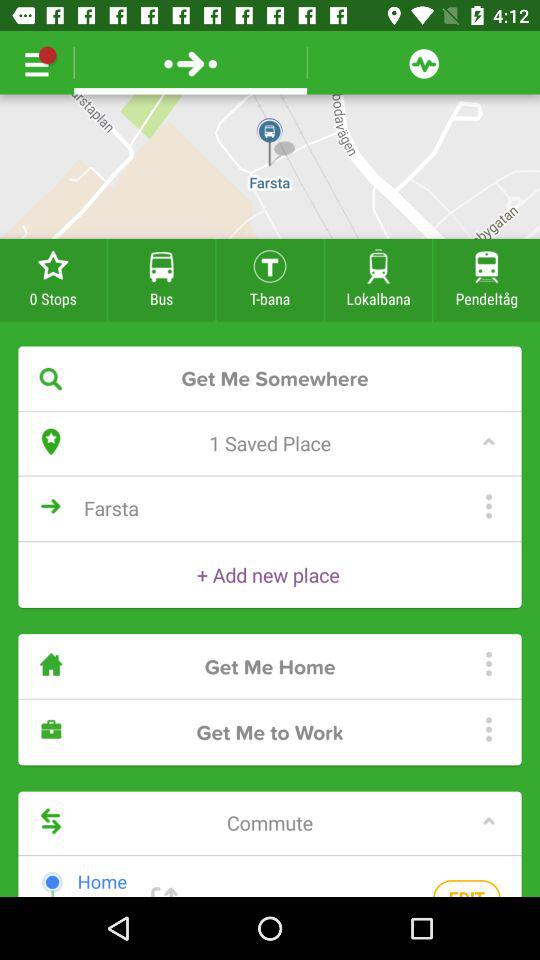What is the name of the saved place? The name of the saved place is Farsta. 